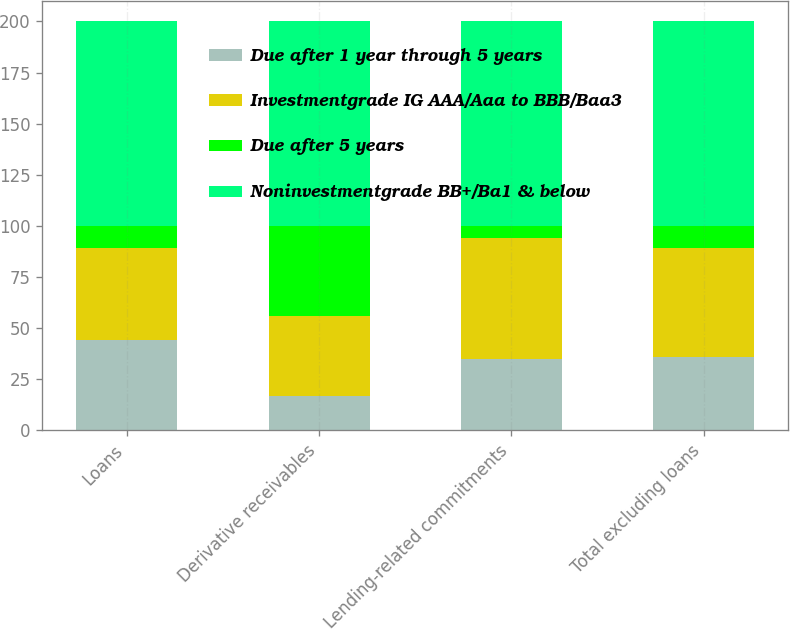Convert chart. <chart><loc_0><loc_0><loc_500><loc_500><stacked_bar_chart><ecel><fcel>Loans<fcel>Derivative receivables<fcel>Lending-related commitments<fcel>Total excluding loans<nl><fcel>Due after 1 year through 5 years<fcel>44<fcel>17<fcel>35<fcel>36<nl><fcel>Investmentgrade IG AAA/Aaa to BBB/Baa3<fcel>45<fcel>39<fcel>59<fcel>53<nl><fcel>Due after 5 years<fcel>11<fcel>44<fcel>6<fcel>11<nl><fcel>Noninvestmentgrade BB+/Ba1 & below<fcel>100<fcel>100<fcel>100<fcel>100<nl></chart> 